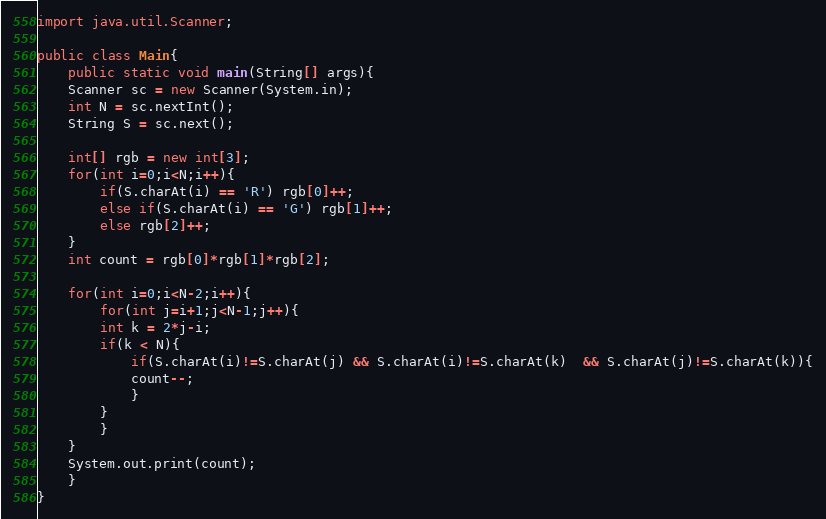<code> <loc_0><loc_0><loc_500><loc_500><_Java_>import java.util.Scanner;

public class Main{
    public static void main(String[] args){
	Scanner sc = new Scanner(System.in);
	int N = sc.nextInt();
	String S = sc.next();
	
	int[] rgb = new int[3];
	for(int i=0;i<N;i++){
	    if(S.charAt(i) == 'R') rgb[0]++;
	    else if(S.charAt(i) == 'G') rgb[1]++;
	    else rgb[2]++;
	}
	int count = rgb[0]*rgb[1]*rgb[2];
	
	for(int i=0;i<N-2;i++){
	    for(int j=i+1;j<N-1;j++){
		int k = 2*j-i;
		if(k < N){
		    if(S.charAt(i)!=S.charAt(j) && S.charAt(i)!=S.charAt(k)  && S.charAt(j)!=S.charAt(k)){
			count--;
		    }
		}
	    }
	}
	System.out.print(count);
    }
}
</code> 